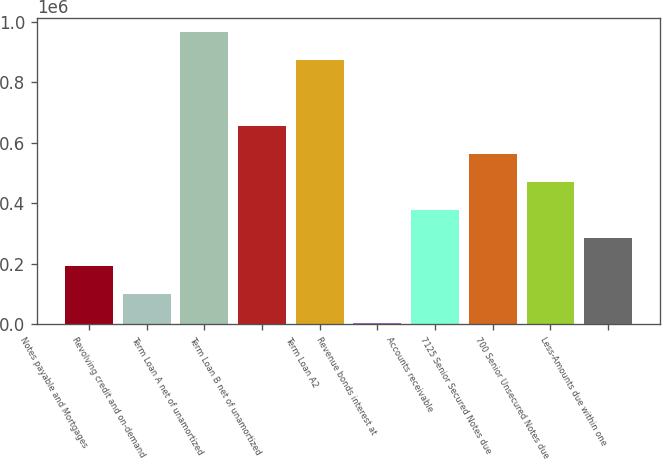Convert chart. <chart><loc_0><loc_0><loc_500><loc_500><bar_chart><fcel>Notes payable and Mortgages<fcel>Revolving credit and on-demand<fcel>Term Loan A net of unamortized<fcel>Term Loan B net of unamortized<fcel>Term Loan A2<fcel>Revenue bonds interest at<fcel>Accounts receivable<fcel>7125 Senior Secured Notes due<fcel>700 Senior Unsecured Notes due<fcel>Less-Amounts due within one<nl><fcel>191302<fcel>98300.8<fcel>964876<fcel>656306<fcel>871875<fcel>5300<fcel>377303<fcel>563305<fcel>470304<fcel>284302<nl></chart> 